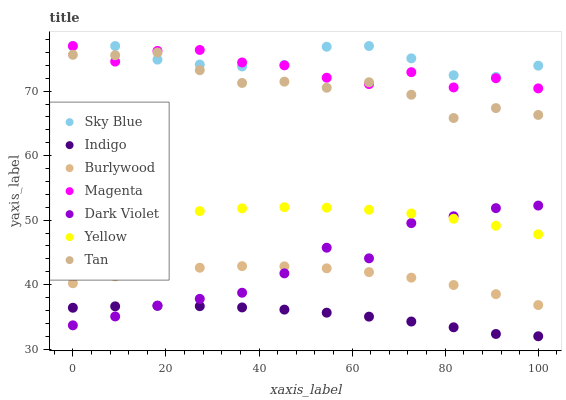Does Indigo have the minimum area under the curve?
Answer yes or no. Yes. Does Sky Blue have the maximum area under the curve?
Answer yes or no. Yes. Does Burlywood have the minimum area under the curve?
Answer yes or no. No. Does Burlywood have the maximum area under the curve?
Answer yes or no. No. Is Indigo the smoothest?
Answer yes or no. Yes. Is Magenta the roughest?
Answer yes or no. Yes. Is Burlywood the smoothest?
Answer yes or no. No. Is Burlywood the roughest?
Answer yes or no. No. Does Indigo have the lowest value?
Answer yes or no. Yes. Does Burlywood have the lowest value?
Answer yes or no. No. Does Magenta have the highest value?
Answer yes or no. Yes. Does Burlywood have the highest value?
Answer yes or no. No. Is Dark Violet less than Sky Blue?
Answer yes or no. Yes. Is Sky Blue greater than Dark Violet?
Answer yes or no. Yes. Does Dark Violet intersect Indigo?
Answer yes or no. Yes. Is Dark Violet less than Indigo?
Answer yes or no. No. Is Dark Violet greater than Indigo?
Answer yes or no. No. Does Dark Violet intersect Sky Blue?
Answer yes or no. No. 